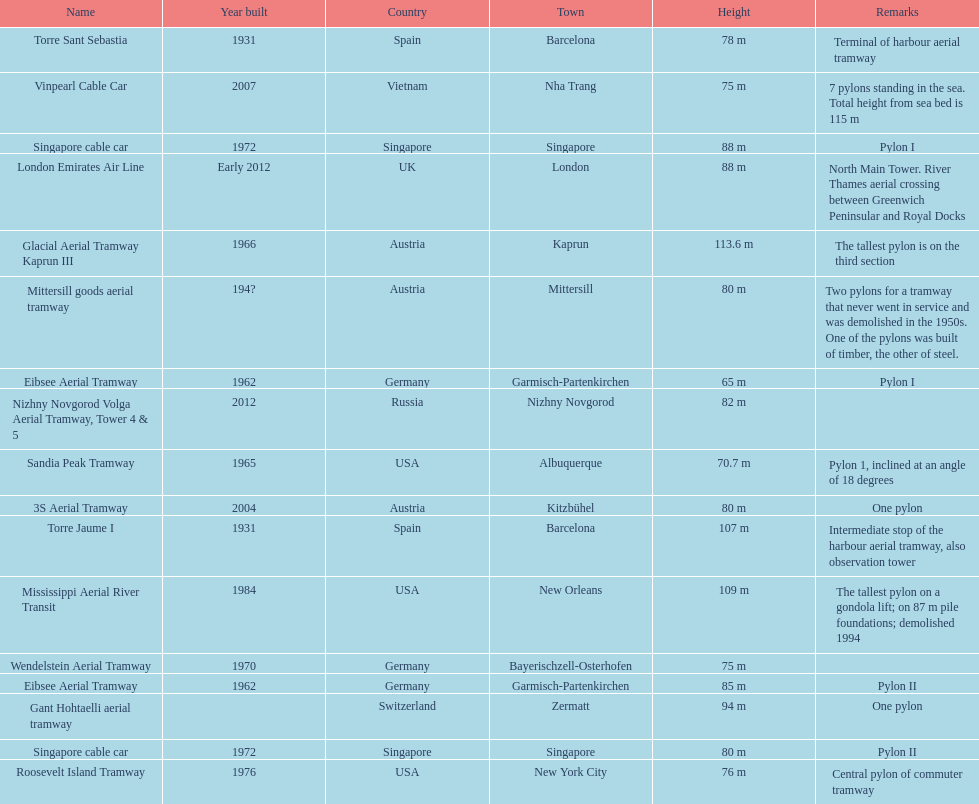How many metres is the tallest pylon? 113.6 m. 